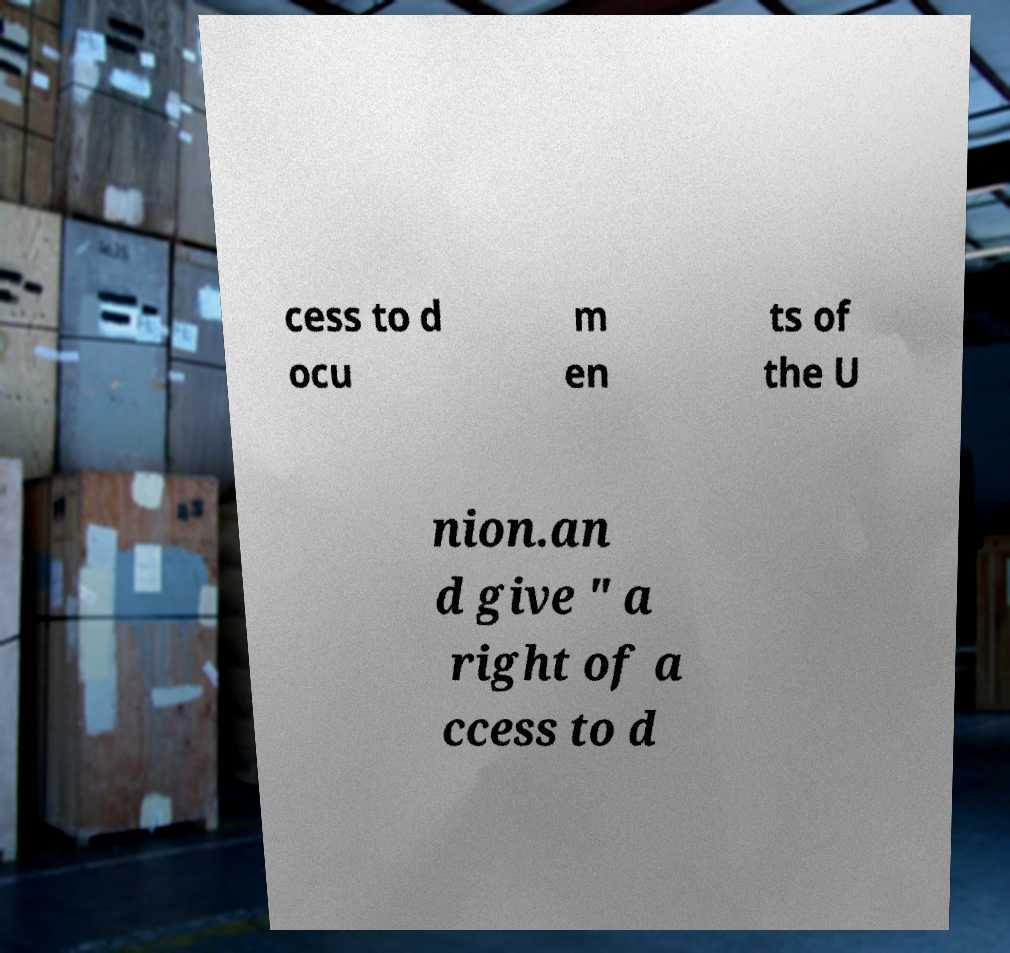I need the written content from this picture converted into text. Can you do that? cess to d ocu m en ts of the U nion.an d give ″ a right of a ccess to d 